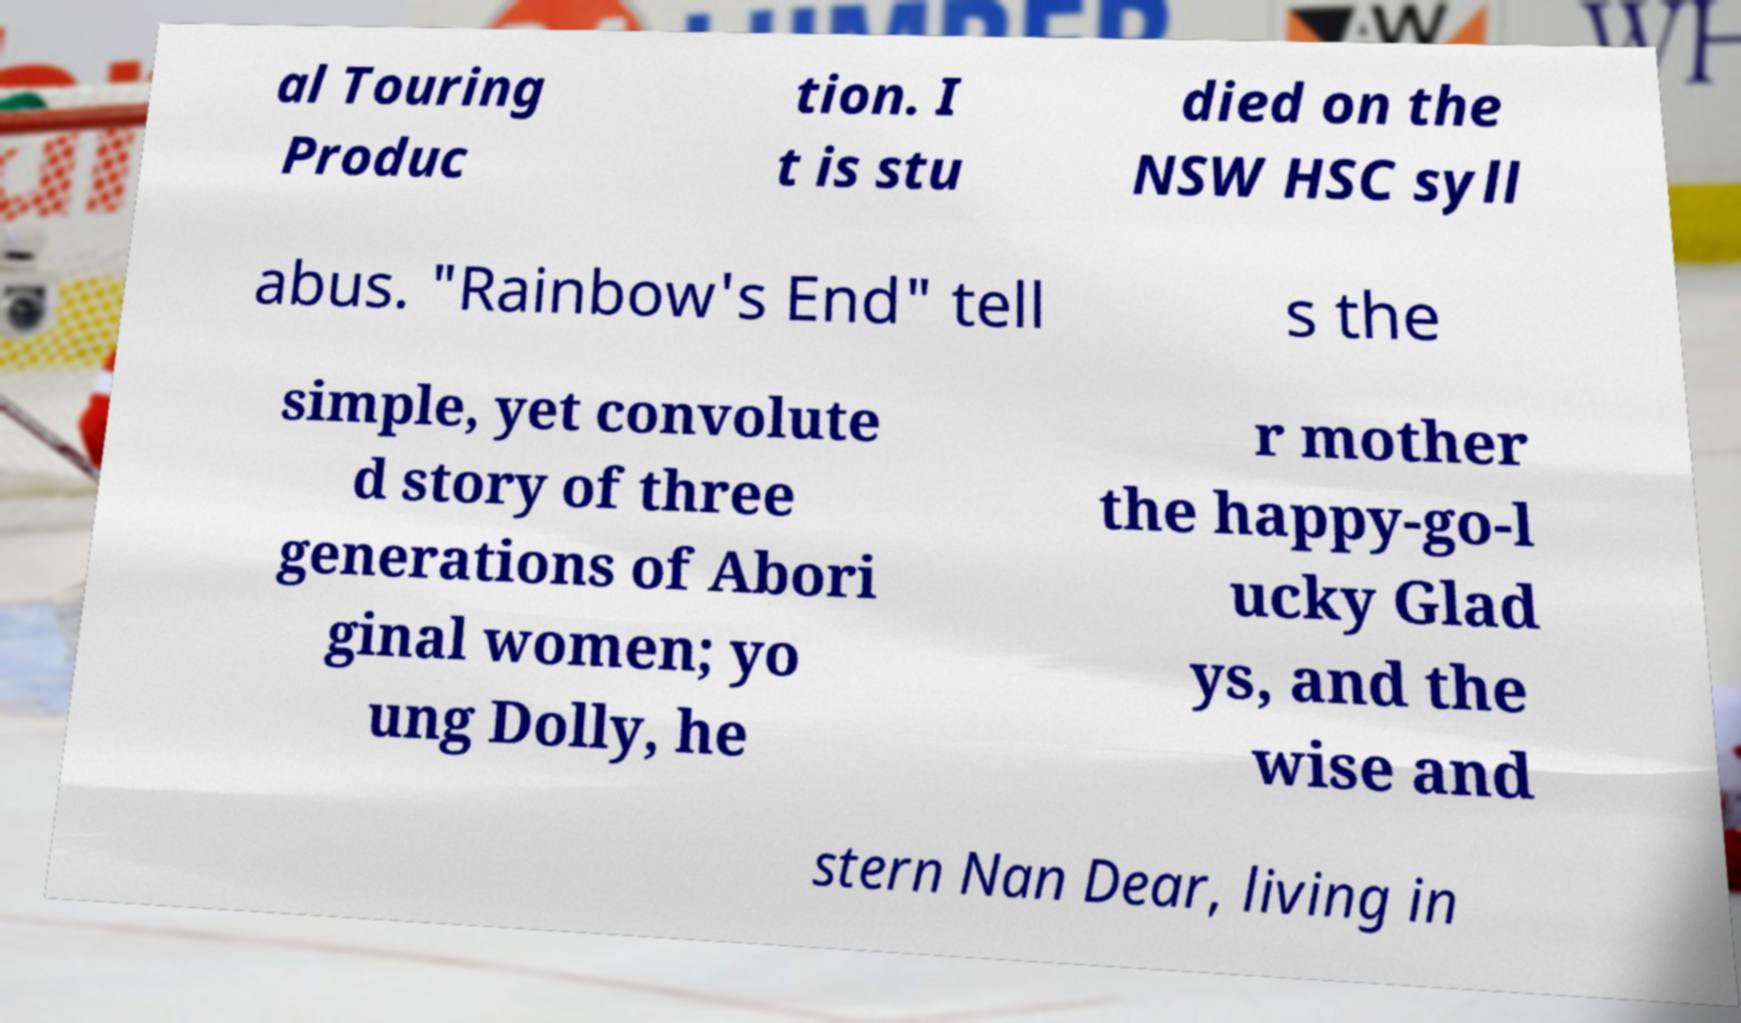There's text embedded in this image that I need extracted. Can you transcribe it verbatim? al Touring Produc tion. I t is stu died on the NSW HSC syll abus. "Rainbow's End" tell s the simple, yet convolute d story of three generations of Abori ginal women; yo ung Dolly, he r mother the happy-go-l ucky Glad ys, and the wise and stern Nan Dear, living in 